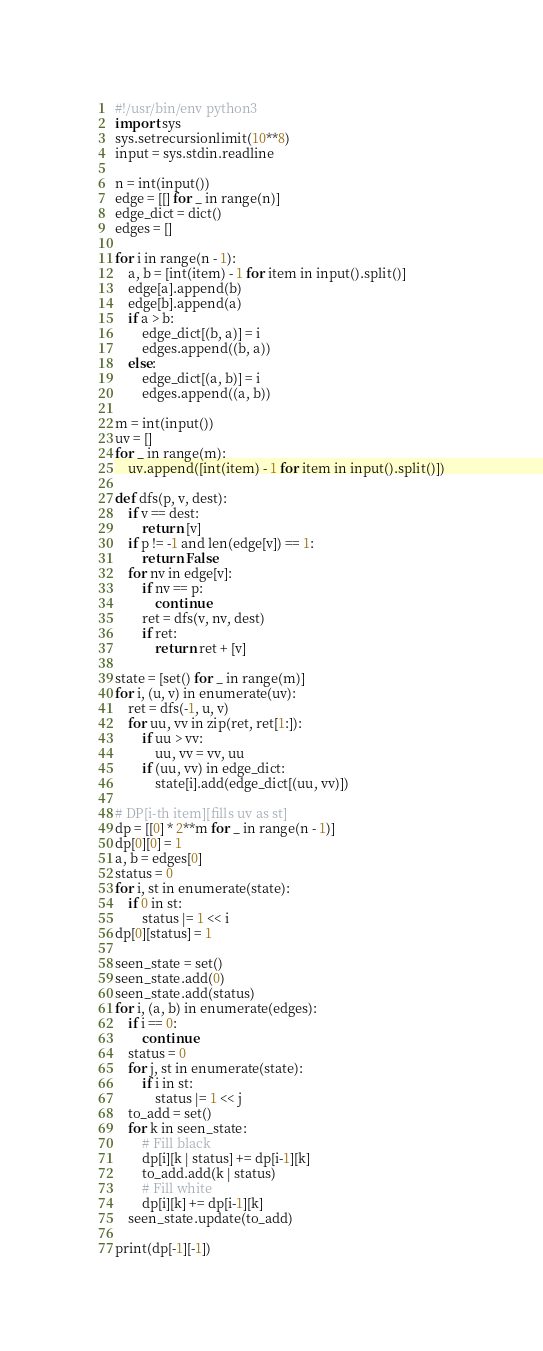Convert code to text. <code><loc_0><loc_0><loc_500><loc_500><_Python_>#!/usr/bin/env python3
import sys
sys.setrecursionlimit(10**8)
input = sys.stdin.readline

n = int(input())
edge = [[] for _ in range(n)]
edge_dict = dict()
edges = []

for i in range(n - 1):
    a, b = [int(item) - 1 for item in input().split()]
    edge[a].append(b)
    edge[b].append(a)
    if a > b:
        edge_dict[(b, a)] = i
        edges.append((b, a))
    else:
        edge_dict[(a, b)] = i
        edges.append((a, b))

m = int(input())
uv = []
for _ in range(m):
    uv.append([int(item) - 1 for item in input().split()])

def dfs(p, v, dest):
    if v == dest:
        return [v]
    if p != -1 and len(edge[v]) == 1:
        return False
    for nv in edge[v]:
        if nv == p:
            continue
        ret = dfs(v, nv, dest)
        if ret:
            return ret + [v]

state = [set() for _ in range(m)]
for i, (u, v) in enumerate(uv):
    ret = dfs(-1, u, v)
    for uu, vv in zip(ret, ret[1:]):
        if uu > vv:
            uu, vv = vv, uu
        if (uu, vv) in edge_dict:
            state[i].add(edge_dict[(uu, vv)])

# DP[i-th item][fills uv as st]
dp = [[0] * 2**m for _ in range(n - 1)]
dp[0][0] = 1
a, b = edges[0]
status = 0
for i, st in enumerate(state):
    if 0 in st:
        status |= 1 << i
dp[0][status] = 1

seen_state = set()
seen_state.add(0)
seen_state.add(status)
for i, (a, b) in enumerate(edges):
    if i == 0:
        continue
    status = 0
    for j, st in enumerate(state):
        if i in st:
            status |= 1 << j
    to_add = set()
    for k in seen_state:
        # Fill black
        dp[i][k | status] += dp[i-1][k]
        to_add.add(k | status)
        # Fill white
        dp[i][k] += dp[i-1][k]
    seen_state.update(to_add)

print(dp[-1][-1])</code> 